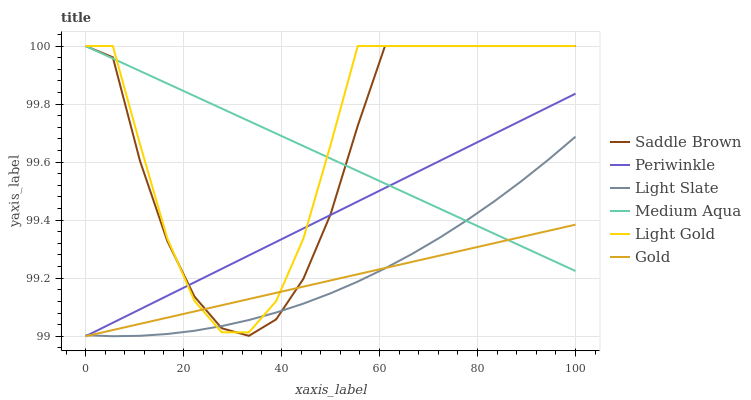Does Gold have the minimum area under the curve?
Answer yes or no. Yes. Does Light Gold have the maximum area under the curve?
Answer yes or no. Yes. Does Light Slate have the minimum area under the curve?
Answer yes or no. No. Does Light Slate have the maximum area under the curve?
Answer yes or no. No. Is Medium Aqua the smoothest?
Answer yes or no. Yes. Is Light Gold the roughest?
Answer yes or no. Yes. Is Light Slate the smoothest?
Answer yes or no. No. Is Light Slate the roughest?
Answer yes or no. No. Does Gold have the lowest value?
Answer yes or no. Yes. Does Light Slate have the lowest value?
Answer yes or no. No. Does Saddle Brown have the highest value?
Answer yes or no. Yes. Does Light Slate have the highest value?
Answer yes or no. No. Does Light Slate intersect Light Gold?
Answer yes or no. Yes. Is Light Slate less than Light Gold?
Answer yes or no. No. Is Light Slate greater than Light Gold?
Answer yes or no. No. 